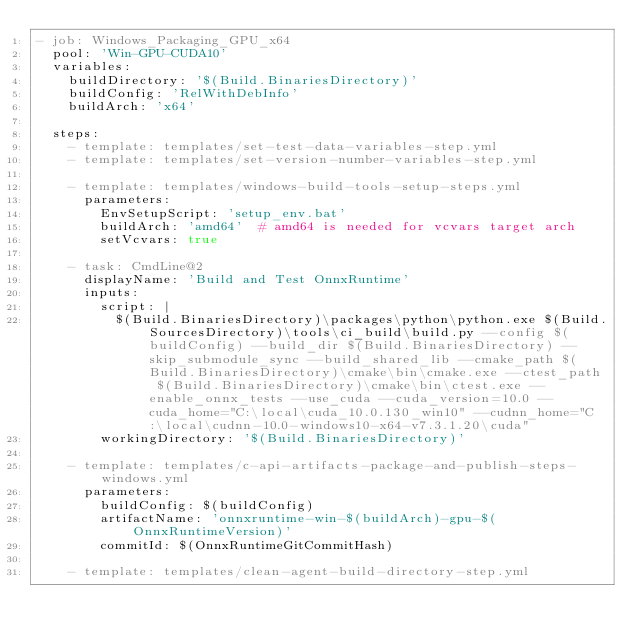<code> <loc_0><loc_0><loc_500><loc_500><_YAML_>- job: Windows_Packaging_GPU_x64
  pool: 'Win-GPU-CUDA10'
  variables:
    buildDirectory: '$(Build.BinariesDirectory)'
    buildConfig: 'RelWithDebInfo'
    buildArch: 'x64'

  steps:
    - template: templates/set-test-data-variables-step.yml
    - template: templates/set-version-number-variables-step.yml

    - template: templates/windows-build-tools-setup-steps.yml
      parameters:
        EnvSetupScript: 'setup_env.bat'
        buildArch: 'amd64'  # amd64 is needed for vcvars target arch
        setVcvars: true

    - task: CmdLine@2
      displayName: 'Build and Test OnnxRuntime'
      inputs:
        script: |
          $(Build.BinariesDirectory)\packages\python\python.exe $(Build.SourcesDirectory)\tools\ci_build\build.py --config $(buildConfig) --build_dir $(Build.BinariesDirectory) --skip_submodule_sync --build_shared_lib --cmake_path $(Build.BinariesDirectory)\cmake\bin\cmake.exe --ctest_path $(Build.BinariesDirectory)\cmake\bin\ctest.exe --enable_onnx_tests --use_cuda --cuda_version=10.0 --cuda_home="C:\local\cuda_10.0.130_win10" --cudnn_home="C:\local\cudnn-10.0-windows10-x64-v7.3.1.20\cuda"
        workingDirectory: '$(Build.BinariesDirectory)'

    - template: templates/c-api-artifacts-package-and-publish-steps-windows.yml
      parameters:
        buildConfig: $(buildConfig)
        artifactName: 'onnxruntime-win-$(buildArch)-gpu-$(OnnxRuntimeVersion)'
        commitId: $(OnnxRuntimeGitCommitHash)

    - template: templates/clean-agent-build-directory-step.yml</code> 